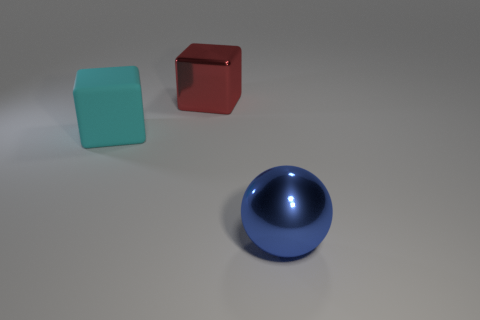There is a big red thing that is the same shape as the large cyan matte thing; what is its material?
Your answer should be very brief. Metal. How many shiny things are tiny cyan blocks or big blue things?
Provide a short and direct response. 1. Is the material of the block that is behind the large cyan object the same as the big blue thing that is right of the large cyan rubber thing?
Make the answer very short. Yes. Are there any large green metal spheres?
Your answer should be compact. No. There is a big shiny object that is right of the metal block; is its shape the same as the thing left of the red thing?
Provide a succinct answer. No. Is there a purple block that has the same material as the big sphere?
Make the answer very short. No. Is the material of the red block behind the cyan block the same as the blue sphere?
Provide a short and direct response. Yes. Are there more big red metal cubes on the left side of the red block than large metal balls that are on the left side of the cyan block?
Provide a succinct answer. No. The metallic ball that is the same size as the red thing is what color?
Your response must be concise. Blue. Is there another large block of the same color as the matte cube?
Your answer should be compact. No. 